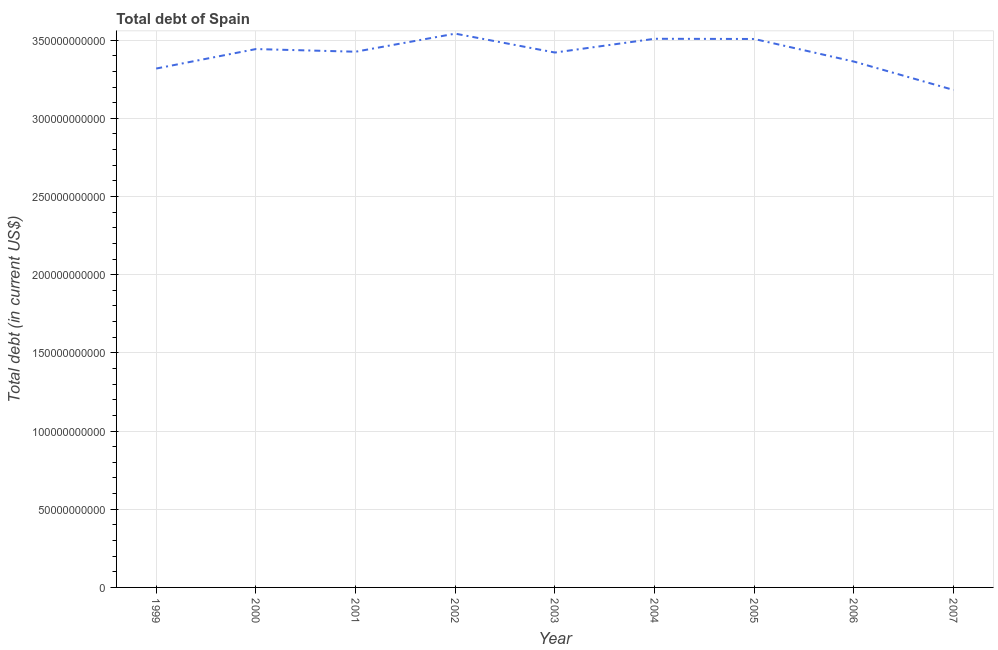What is the total debt in 2007?
Offer a terse response. 3.18e+11. Across all years, what is the maximum total debt?
Provide a short and direct response. 3.54e+11. Across all years, what is the minimum total debt?
Offer a very short reply. 3.18e+11. In which year was the total debt minimum?
Give a very brief answer. 2007. What is the sum of the total debt?
Offer a terse response. 3.07e+12. What is the difference between the total debt in 2004 and 2007?
Your answer should be very brief. 3.27e+1. What is the average total debt per year?
Your response must be concise. 3.41e+11. What is the median total debt?
Your answer should be compact. 3.43e+11. In how many years, is the total debt greater than 30000000000 US$?
Your response must be concise. 9. What is the ratio of the total debt in 2003 to that in 2005?
Give a very brief answer. 0.98. Is the difference between the total debt in 1999 and 2000 greater than the difference between any two years?
Give a very brief answer. No. What is the difference between the highest and the second highest total debt?
Your answer should be very brief. 3.29e+09. What is the difference between the highest and the lowest total debt?
Offer a very short reply. 3.60e+1. In how many years, is the total debt greater than the average total debt taken over all years?
Your answer should be compact. 6. How many years are there in the graph?
Ensure brevity in your answer.  9. Are the values on the major ticks of Y-axis written in scientific E-notation?
Your answer should be compact. No. Does the graph contain any zero values?
Make the answer very short. No. Does the graph contain grids?
Your answer should be very brief. Yes. What is the title of the graph?
Offer a terse response. Total debt of Spain. What is the label or title of the Y-axis?
Your answer should be compact. Total debt (in current US$). What is the Total debt (in current US$) in 1999?
Provide a succinct answer. 3.32e+11. What is the Total debt (in current US$) in 2000?
Ensure brevity in your answer.  3.44e+11. What is the Total debt (in current US$) in 2001?
Your answer should be very brief. 3.43e+11. What is the Total debt (in current US$) of 2002?
Ensure brevity in your answer.  3.54e+11. What is the Total debt (in current US$) in 2003?
Your response must be concise. 3.42e+11. What is the Total debt (in current US$) of 2004?
Provide a succinct answer. 3.51e+11. What is the Total debt (in current US$) in 2005?
Keep it short and to the point. 3.51e+11. What is the Total debt (in current US$) of 2006?
Provide a succinct answer. 3.36e+11. What is the Total debt (in current US$) in 2007?
Your response must be concise. 3.18e+11. What is the difference between the Total debt (in current US$) in 1999 and 2000?
Provide a short and direct response. -1.25e+1. What is the difference between the Total debt (in current US$) in 1999 and 2001?
Offer a terse response. -1.08e+1. What is the difference between the Total debt (in current US$) in 1999 and 2002?
Make the answer very short. -2.23e+1. What is the difference between the Total debt (in current US$) in 1999 and 2003?
Provide a short and direct response. -1.02e+1. What is the difference between the Total debt (in current US$) in 1999 and 2004?
Provide a short and direct response. -1.90e+1. What is the difference between the Total debt (in current US$) in 1999 and 2005?
Offer a very short reply. -1.89e+1. What is the difference between the Total debt (in current US$) in 1999 and 2006?
Keep it short and to the point. -4.45e+09. What is the difference between the Total debt (in current US$) in 1999 and 2007?
Make the answer very short. 1.37e+1. What is the difference between the Total debt (in current US$) in 2000 and 2001?
Keep it short and to the point. 1.70e+09. What is the difference between the Total debt (in current US$) in 2000 and 2002?
Make the answer very short. -9.86e+09. What is the difference between the Total debt (in current US$) in 2000 and 2003?
Keep it short and to the point. 2.22e+09. What is the difference between the Total debt (in current US$) in 2000 and 2004?
Give a very brief answer. -6.57e+09. What is the difference between the Total debt (in current US$) in 2000 and 2005?
Offer a terse response. -6.45e+09. What is the difference between the Total debt (in current US$) in 2000 and 2006?
Your answer should be very brief. 8.01e+09. What is the difference between the Total debt (in current US$) in 2000 and 2007?
Your response must be concise. 2.62e+1. What is the difference between the Total debt (in current US$) in 2001 and 2002?
Provide a short and direct response. -1.16e+1. What is the difference between the Total debt (in current US$) in 2001 and 2003?
Keep it short and to the point. 5.18e+08. What is the difference between the Total debt (in current US$) in 2001 and 2004?
Provide a succinct answer. -8.27e+09. What is the difference between the Total debt (in current US$) in 2001 and 2005?
Your answer should be compact. -8.15e+09. What is the difference between the Total debt (in current US$) in 2001 and 2006?
Offer a terse response. 6.31e+09. What is the difference between the Total debt (in current US$) in 2001 and 2007?
Provide a short and direct response. 2.45e+1. What is the difference between the Total debt (in current US$) in 2002 and 2003?
Keep it short and to the point. 1.21e+1. What is the difference between the Total debt (in current US$) in 2002 and 2004?
Your answer should be very brief. 3.29e+09. What is the difference between the Total debt (in current US$) in 2002 and 2005?
Ensure brevity in your answer.  3.41e+09. What is the difference between the Total debt (in current US$) in 2002 and 2006?
Keep it short and to the point. 1.79e+1. What is the difference between the Total debt (in current US$) in 2002 and 2007?
Offer a terse response. 3.60e+1. What is the difference between the Total debt (in current US$) in 2003 and 2004?
Provide a succinct answer. -8.79e+09. What is the difference between the Total debt (in current US$) in 2003 and 2005?
Give a very brief answer. -8.67e+09. What is the difference between the Total debt (in current US$) in 2003 and 2006?
Make the answer very short. 5.79e+09. What is the difference between the Total debt (in current US$) in 2003 and 2007?
Your answer should be compact. 2.39e+1. What is the difference between the Total debt (in current US$) in 2004 and 2005?
Your answer should be compact. 1.27e+08. What is the difference between the Total debt (in current US$) in 2004 and 2006?
Your answer should be very brief. 1.46e+1. What is the difference between the Total debt (in current US$) in 2004 and 2007?
Make the answer very short. 3.27e+1. What is the difference between the Total debt (in current US$) in 2005 and 2006?
Your answer should be very brief. 1.45e+1. What is the difference between the Total debt (in current US$) in 2005 and 2007?
Provide a succinct answer. 3.26e+1. What is the difference between the Total debt (in current US$) in 2006 and 2007?
Ensure brevity in your answer.  1.82e+1. What is the ratio of the Total debt (in current US$) in 1999 to that in 2000?
Provide a short and direct response. 0.96. What is the ratio of the Total debt (in current US$) in 1999 to that in 2001?
Offer a terse response. 0.97. What is the ratio of the Total debt (in current US$) in 1999 to that in 2002?
Offer a terse response. 0.94. What is the ratio of the Total debt (in current US$) in 1999 to that in 2004?
Provide a short and direct response. 0.95. What is the ratio of the Total debt (in current US$) in 1999 to that in 2005?
Provide a short and direct response. 0.95. What is the ratio of the Total debt (in current US$) in 1999 to that in 2006?
Give a very brief answer. 0.99. What is the ratio of the Total debt (in current US$) in 1999 to that in 2007?
Make the answer very short. 1.04. What is the ratio of the Total debt (in current US$) in 2000 to that in 2002?
Your answer should be very brief. 0.97. What is the ratio of the Total debt (in current US$) in 2000 to that in 2003?
Your answer should be compact. 1.01. What is the ratio of the Total debt (in current US$) in 2000 to that in 2004?
Provide a succinct answer. 0.98. What is the ratio of the Total debt (in current US$) in 2000 to that in 2005?
Provide a short and direct response. 0.98. What is the ratio of the Total debt (in current US$) in 2000 to that in 2006?
Ensure brevity in your answer.  1.02. What is the ratio of the Total debt (in current US$) in 2000 to that in 2007?
Provide a succinct answer. 1.08. What is the ratio of the Total debt (in current US$) in 2001 to that in 2003?
Your answer should be compact. 1. What is the ratio of the Total debt (in current US$) in 2001 to that in 2004?
Provide a short and direct response. 0.98. What is the ratio of the Total debt (in current US$) in 2001 to that in 2006?
Give a very brief answer. 1.02. What is the ratio of the Total debt (in current US$) in 2001 to that in 2007?
Ensure brevity in your answer.  1.08. What is the ratio of the Total debt (in current US$) in 2002 to that in 2003?
Offer a terse response. 1.03. What is the ratio of the Total debt (in current US$) in 2002 to that in 2004?
Give a very brief answer. 1.01. What is the ratio of the Total debt (in current US$) in 2002 to that in 2005?
Provide a succinct answer. 1.01. What is the ratio of the Total debt (in current US$) in 2002 to that in 2006?
Your answer should be very brief. 1.05. What is the ratio of the Total debt (in current US$) in 2002 to that in 2007?
Make the answer very short. 1.11. What is the ratio of the Total debt (in current US$) in 2003 to that in 2004?
Make the answer very short. 0.97. What is the ratio of the Total debt (in current US$) in 2003 to that in 2005?
Provide a short and direct response. 0.97. What is the ratio of the Total debt (in current US$) in 2003 to that in 2006?
Provide a short and direct response. 1.02. What is the ratio of the Total debt (in current US$) in 2003 to that in 2007?
Make the answer very short. 1.07. What is the ratio of the Total debt (in current US$) in 2004 to that in 2006?
Ensure brevity in your answer.  1.04. What is the ratio of the Total debt (in current US$) in 2004 to that in 2007?
Make the answer very short. 1.1. What is the ratio of the Total debt (in current US$) in 2005 to that in 2006?
Ensure brevity in your answer.  1.04. What is the ratio of the Total debt (in current US$) in 2005 to that in 2007?
Your answer should be very brief. 1.1. What is the ratio of the Total debt (in current US$) in 2006 to that in 2007?
Provide a short and direct response. 1.06. 